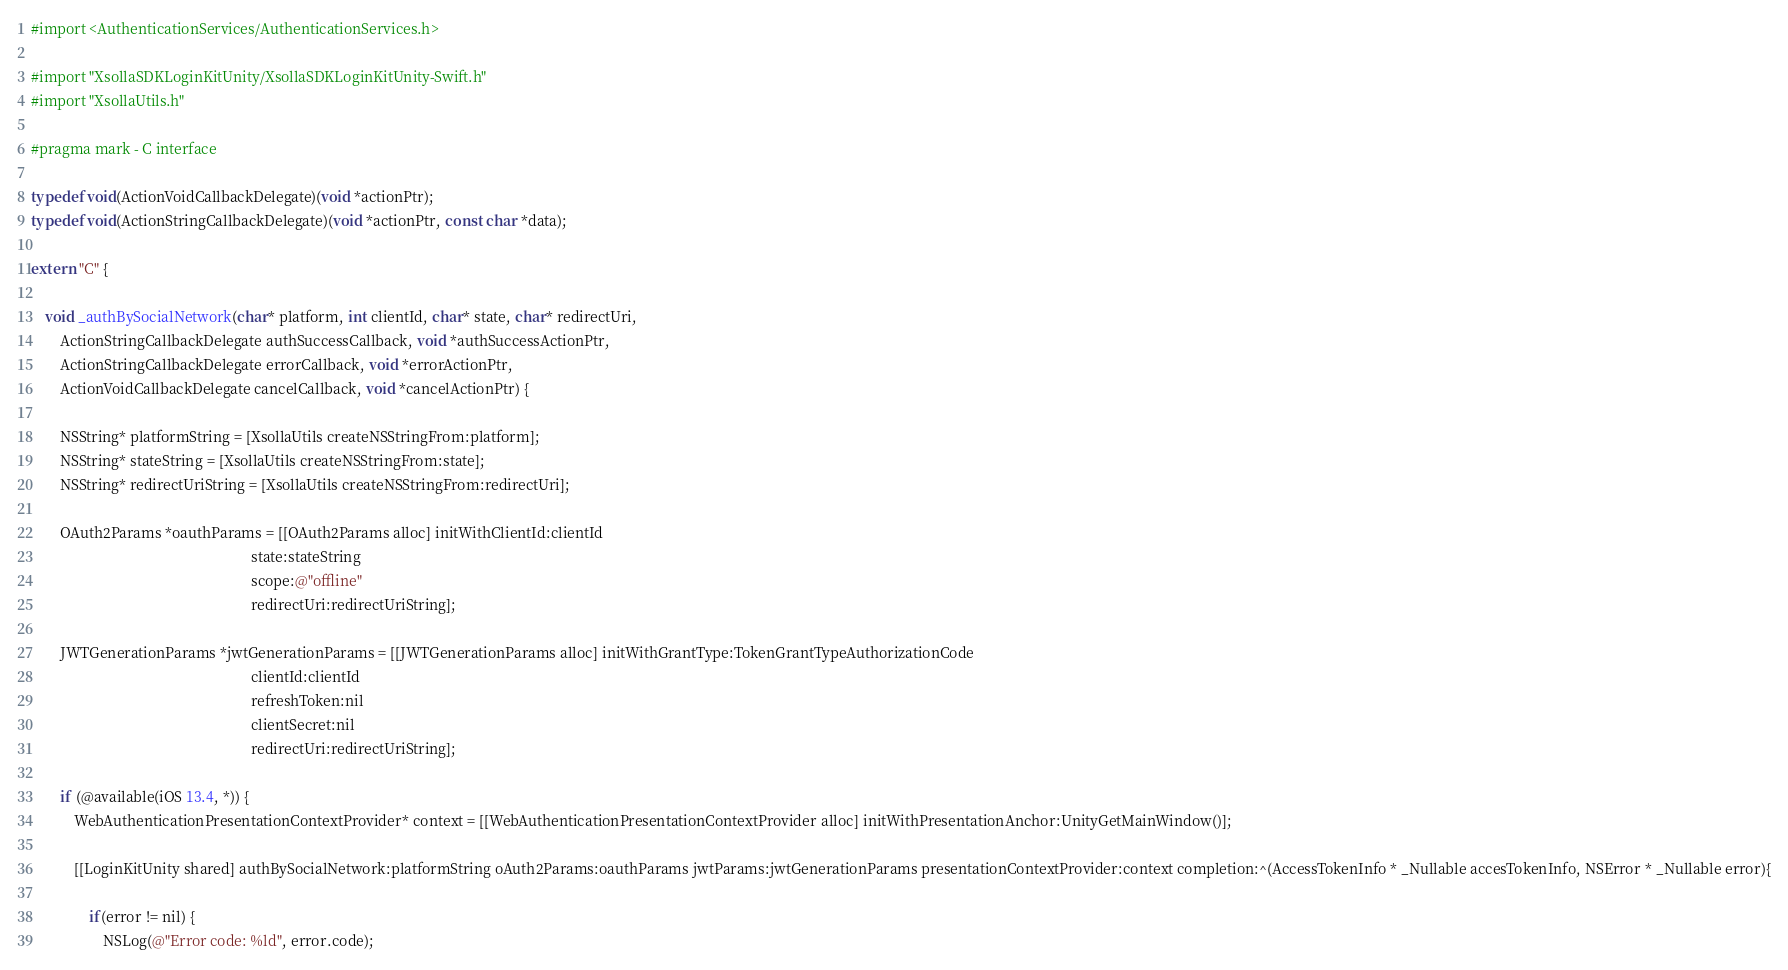<code> <loc_0><loc_0><loc_500><loc_500><_ObjectiveC_>#import <AuthenticationServices/AuthenticationServices.h>

#import "XsollaSDKLoginKitUnity/XsollaSDKLoginKitUnity-Swift.h"
#import "XsollaUtils.h"

#pragma mark - C interface

typedef void(ActionVoidCallbackDelegate)(void *actionPtr);
typedef void(ActionStringCallbackDelegate)(void *actionPtr, const char *data);

extern "C" {

	void _authBySocialNetwork(char* platform, int clientId, char* state, char* redirectUri,
		ActionStringCallbackDelegate authSuccessCallback, void *authSuccessActionPtr,
		ActionStringCallbackDelegate errorCallback, void *errorActionPtr,
		ActionVoidCallbackDelegate cancelCallback, void *cancelActionPtr) {

		NSString* platformString = [XsollaUtils createNSStringFrom:platform];
		NSString* stateString = [XsollaUtils createNSStringFrom:state];
		NSString* redirectUriString = [XsollaUtils createNSStringFrom:redirectUri];

		OAuth2Params *oauthParams = [[OAuth2Params alloc] initWithClientId:clientId
															 state:stateString
															 scope:@"offline"
															 redirectUri:redirectUriString];

		JWTGenerationParams *jwtGenerationParams = [[JWTGenerationParams alloc] initWithGrantType:TokenGrantTypeAuthorizationCode
															 clientId:clientId
															 refreshToken:nil
															 clientSecret:nil
															 redirectUri:redirectUriString];

		if (@available(iOS 13.4, *)) {
			WebAuthenticationPresentationContextProvider* context = [[WebAuthenticationPresentationContextProvider alloc] initWithPresentationAnchor:UnityGetMainWindow()];

			[[LoginKitUnity shared] authBySocialNetwork:platformString oAuth2Params:oauthParams jwtParams:jwtGenerationParams presentationContextProvider:context completion:^(AccessTokenInfo * _Nullable accesTokenInfo, NSError * _Nullable error){

				if(error != nil) {
					NSLog(@"Error code: %ld", error.code);
</code> 